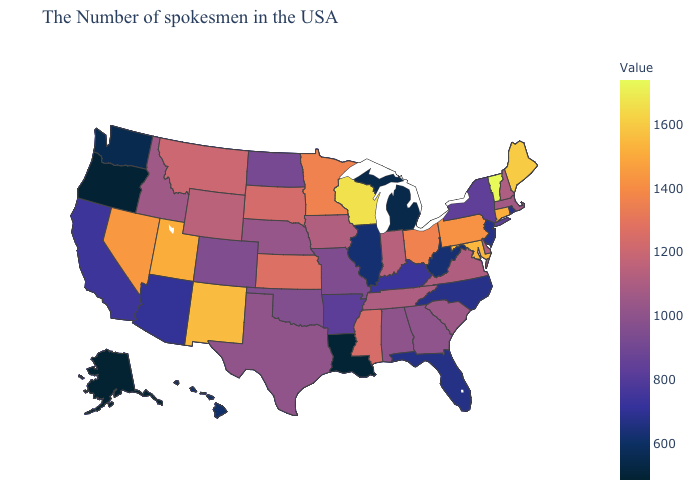Among the states that border Alabama , which have the lowest value?
Answer briefly. Florida. Does Vermont have the highest value in the USA?
Short answer required. Yes. Which states have the highest value in the USA?
Write a very short answer. Vermont. 